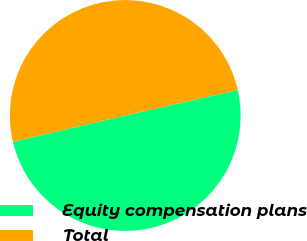<chart> <loc_0><loc_0><loc_500><loc_500><pie_chart><fcel>Equity compensation plans<fcel>Total<nl><fcel>49.89%<fcel>50.11%<nl></chart> 